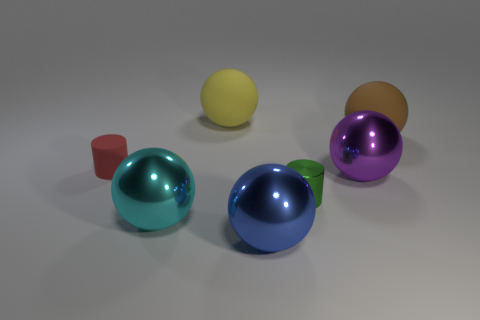How many other things are there of the same material as the large yellow thing?
Your answer should be compact. 2. What is the material of the large brown thing?
Offer a very short reply. Rubber. How big is the rubber thing that is in front of the brown rubber thing?
Keep it short and to the point. Small. What number of rubber balls are on the left side of the large matte object that is on the right side of the small green cylinder?
Your answer should be compact. 1. There is a matte thing that is right of the purple metallic sphere; is it the same shape as the big yellow matte thing behind the tiny red rubber cylinder?
Make the answer very short. Yes. How many things are behind the tiny rubber cylinder and in front of the small metallic cylinder?
Your answer should be very brief. 0. Is there a big matte block that has the same color as the small metal thing?
Your answer should be compact. No. What is the shape of the cyan thing that is the same size as the blue thing?
Make the answer very short. Sphere. Are there any large metal objects behind the large blue thing?
Keep it short and to the point. Yes. Is the cylinder in front of the tiny red thing made of the same material as the thing that is right of the purple sphere?
Your answer should be very brief. No. 